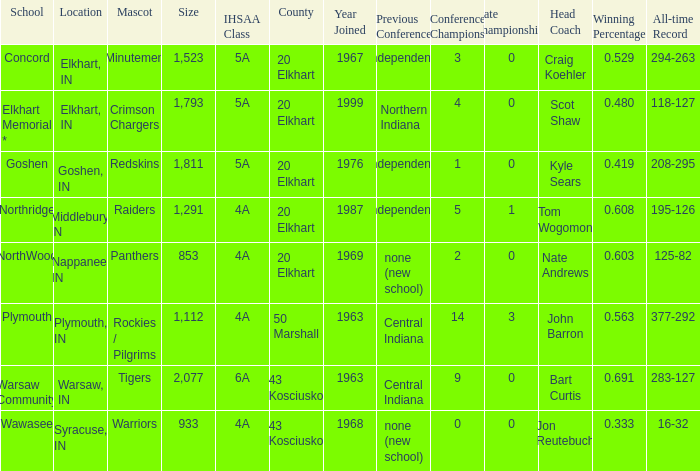What is the IHSAA class for the team located in Middlebury, IN? 4A. 